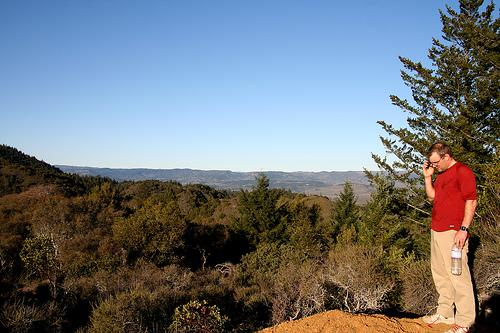Question: what kind of pants is the man wearing?
Choices:
A. Snow pants.
B. Khaki.
C. Jeans.
D. Motorcycle pants.
Answer with the letter. Answer: B Question: what takes up most of the photo?
Choices:
A. Flowers.
B. The table.
C. The ocean.
D. Trees.
Answer with the letter. Answer: D Question: what is the man doing?
Choices:
A. Having a drink.
B. Playing baseball.
C. Catching a frisbee.
D. Using the phone.
Answer with the letter. Answer: D 